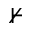<formula> <loc_0><loc_0><loc_500><loc_500>\nvdash</formula> 